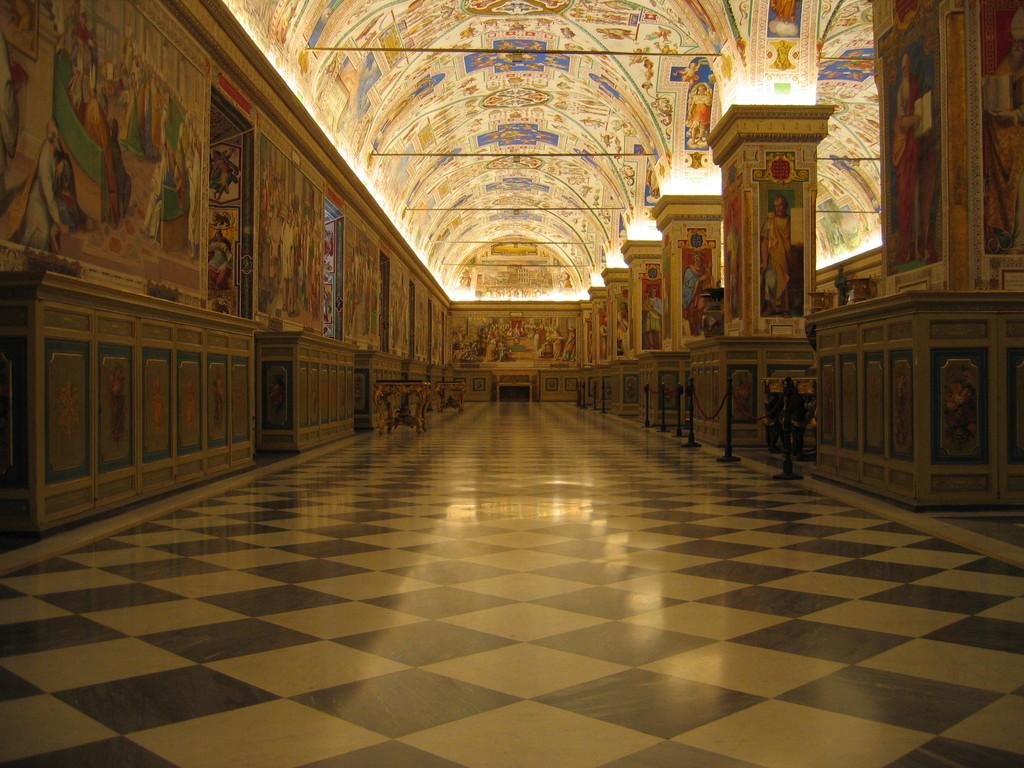Where was the image taken? The image was taken in a museum. What can be seen on the right side of the image? There are pillars on the right side of the image. What is located on the left side of the image? There are tables on the left side of the image. What type of artwork is displayed on the wall in the image? There is a wall with paintings on the left side of the image. How many eyes can be seen on the furniture in the image? There is no furniture with eyes present in the image. 